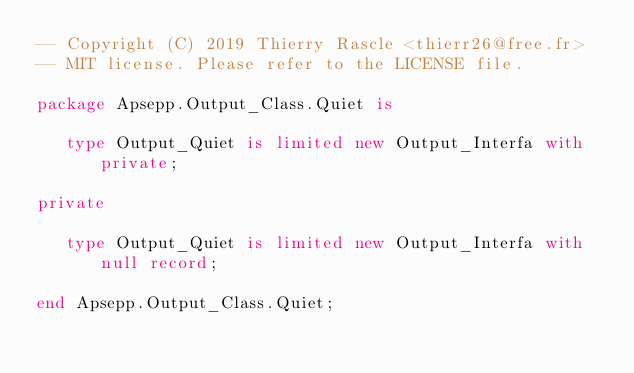Convert code to text. <code><loc_0><loc_0><loc_500><loc_500><_Ada_>-- Copyright (C) 2019 Thierry Rascle <thierr26@free.fr>
-- MIT license. Please refer to the LICENSE file.

package Apsepp.Output_Class.Quiet is

   type Output_Quiet is limited new Output_Interfa with private;

private

   type Output_Quiet is limited new Output_Interfa with null record;

end Apsepp.Output_Class.Quiet;
</code> 